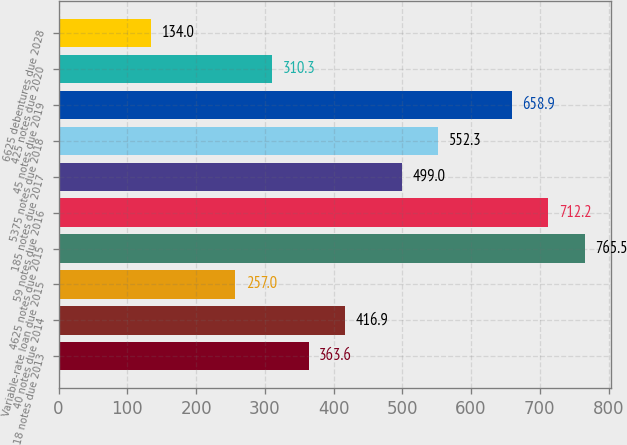<chart> <loc_0><loc_0><loc_500><loc_500><bar_chart><fcel>18 notes due 2013<fcel>40 notes due 2014<fcel>Variable-rate loan due 2015<fcel>4625 notes due 2015<fcel>59 notes due 2016<fcel>185 notes due 2017<fcel>5375 notes due 2018<fcel>45 notes due 2019<fcel>425 notes due 2020<fcel>6625 debentures due 2028<nl><fcel>363.6<fcel>416.9<fcel>257<fcel>765.5<fcel>712.2<fcel>499<fcel>552.3<fcel>658.9<fcel>310.3<fcel>134<nl></chart> 